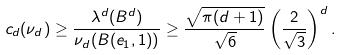<formula> <loc_0><loc_0><loc_500><loc_500>c _ { d } ( \nu _ { d } ) \geq \frac { \lambda ^ { d } ( B ^ { d } ) } { \nu _ { d } ( B ( e _ { 1 } , 1 ) ) } \geq \frac { \sqrt { \pi ( d + 1 ) } } { \sqrt { 6 } } \left ( \frac { 2 } { \sqrt { 3 } } \right ) ^ { d } .</formula> 